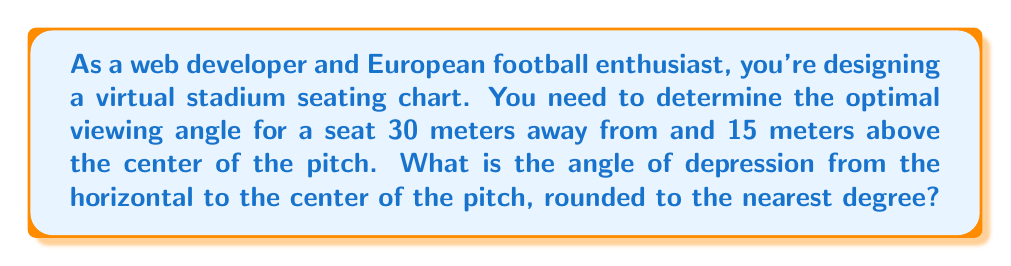Give your solution to this math problem. Let's approach this step-by-step using trigonometry:

1) First, we need to visualize the problem. We have a right triangle where:
   - The adjacent side is the horizontal distance to the pitch center (30 meters)
   - The opposite side is the height above the pitch (15 meters)
   - The angle we're looking for is the angle of depression from the horizontal

2) We can represent this situation with the following diagram:

[asy]
import geometry;

pair A = (0,0), B = (30,0), C = (30,15);
draw(A--B--C--A);
draw(B--(30,-5), arrow=Arrow(TeXHead));
label("30m", (15,-2), S);
label("15m", (31,7.5), E);
label("θ", (29,1), SE);
label("Center of pitch", (0,-2), S);
label("Seat", (31,15), E);
[/asy]

3) To find the angle of depression (θ), we can use the tangent function:

   $$\tan(\theta) = \frac{\text{opposite}}{\text{adjacent}} = \frac{15}{30} = 0.5$$

4) To get θ, we need to take the inverse tangent (arctan or tan^(-1)):

   $$\theta = \tan^{-1}(0.5)$$

5) Using a calculator or programming function:

   $$\theta \approx 26.57°$$

6) Rounding to the nearest degree:

   $$\theta \approx 27°$$

Thus, the optimal viewing angle (angle of depression) is approximately 27 degrees.
Answer: 27° 